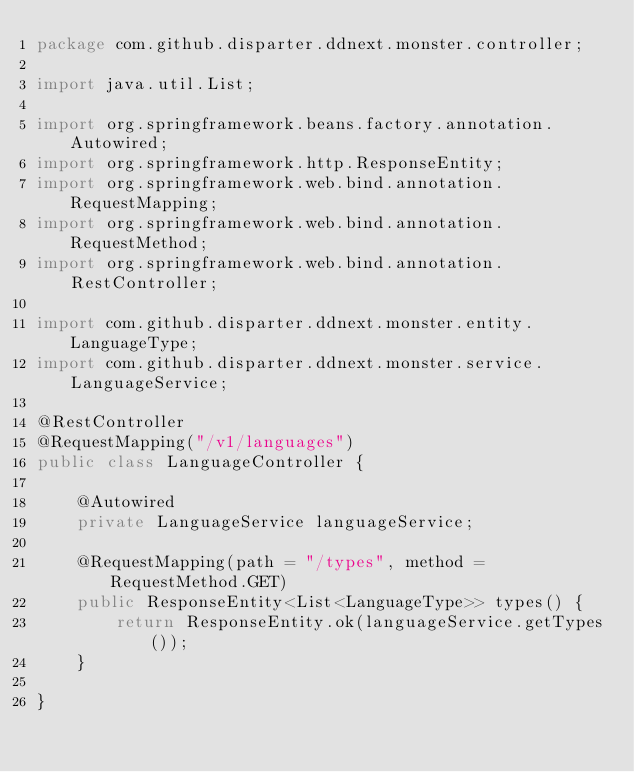Convert code to text. <code><loc_0><loc_0><loc_500><loc_500><_Java_>package com.github.disparter.ddnext.monster.controller;

import java.util.List;

import org.springframework.beans.factory.annotation.Autowired;
import org.springframework.http.ResponseEntity;
import org.springframework.web.bind.annotation.RequestMapping;
import org.springframework.web.bind.annotation.RequestMethod;
import org.springframework.web.bind.annotation.RestController;

import com.github.disparter.ddnext.monster.entity.LanguageType;
import com.github.disparter.ddnext.monster.service.LanguageService;

@RestController
@RequestMapping("/v1/languages")
public class LanguageController {

    @Autowired
    private LanguageService languageService;
    
    @RequestMapping(path = "/types", method = RequestMethod.GET)
    public ResponseEntity<List<LanguageType>> types() {
        return ResponseEntity.ok(languageService.getTypes());
    }
    
}
</code> 